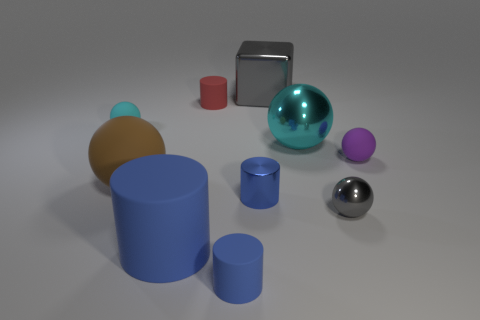Subtract all blue cylinders. How many were subtracted if there are1blue cylinders left? 2 Subtract all purple rubber balls. How many balls are left? 4 Subtract all cylinders. How many objects are left? 6 Subtract 3 balls. How many balls are left? 2 Subtract all purple cylinders. How many gray spheres are left? 1 Subtract all brown objects. Subtract all gray shiny spheres. How many objects are left? 8 Add 2 big brown rubber balls. How many big brown rubber balls are left? 3 Add 7 big blue cylinders. How many big blue cylinders exist? 8 Subtract all cyan balls. How many balls are left? 3 Subtract 0 yellow cubes. How many objects are left? 10 